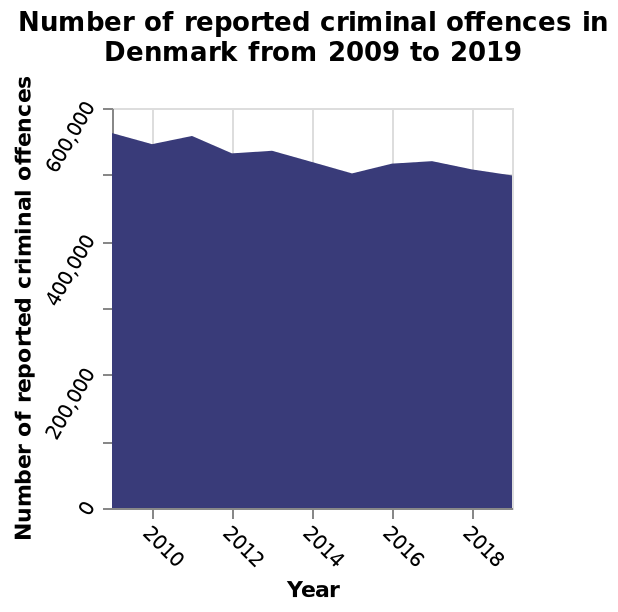<image>
What is the range of the y-axis on the area graph? The y-axis on the area graph has a linear scale ranging from 0 to 600,000. Does the y-axis on the area graph have a logarithmic scale ranging from 0 to 600,000? No.The y-axis on the area graph has a linear scale ranging from 0 to 600,000. 